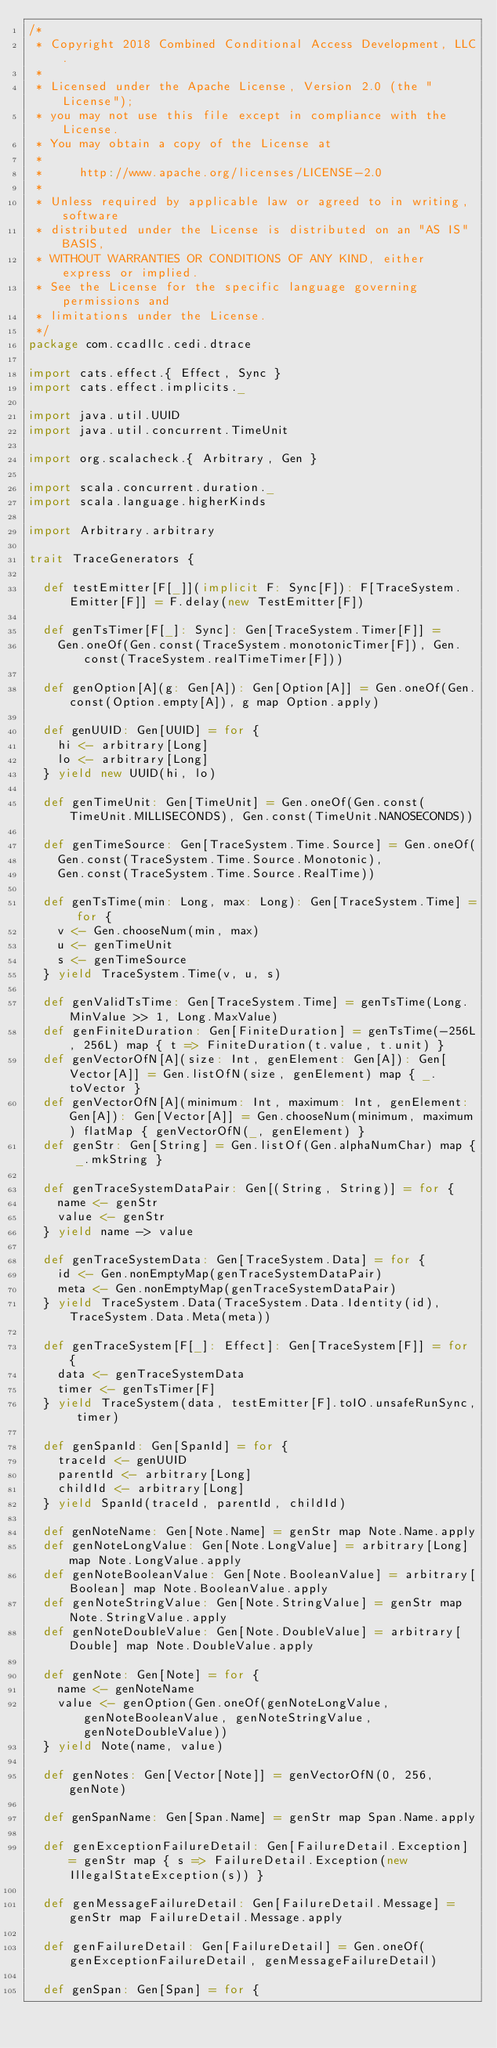<code> <loc_0><loc_0><loc_500><loc_500><_Scala_>/*
 * Copyright 2018 Combined Conditional Access Development, LLC.
 *
 * Licensed under the Apache License, Version 2.0 (the "License");
 * you may not use this file except in compliance with the License.
 * You may obtain a copy of the License at
 *
 *     http://www.apache.org/licenses/LICENSE-2.0
 *
 * Unless required by applicable law or agreed to in writing, software
 * distributed under the License is distributed on an "AS IS" BASIS,
 * WITHOUT WARRANTIES OR CONDITIONS OF ANY KIND, either express or implied.
 * See the License for the specific language governing permissions and
 * limitations under the License.
 */
package com.ccadllc.cedi.dtrace

import cats.effect.{ Effect, Sync }
import cats.effect.implicits._

import java.util.UUID
import java.util.concurrent.TimeUnit

import org.scalacheck.{ Arbitrary, Gen }

import scala.concurrent.duration._
import scala.language.higherKinds

import Arbitrary.arbitrary

trait TraceGenerators {

  def testEmitter[F[_]](implicit F: Sync[F]): F[TraceSystem.Emitter[F]] = F.delay(new TestEmitter[F])

  def genTsTimer[F[_]: Sync]: Gen[TraceSystem.Timer[F]] =
    Gen.oneOf(Gen.const(TraceSystem.monotonicTimer[F]), Gen.const(TraceSystem.realTimeTimer[F]))

  def genOption[A](g: Gen[A]): Gen[Option[A]] = Gen.oneOf(Gen.const(Option.empty[A]), g map Option.apply)

  def genUUID: Gen[UUID] = for {
    hi <- arbitrary[Long]
    lo <- arbitrary[Long]
  } yield new UUID(hi, lo)

  def genTimeUnit: Gen[TimeUnit] = Gen.oneOf(Gen.const(TimeUnit.MILLISECONDS), Gen.const(TimeUnit.NANOSECONDS))

  def genTimeSource: Gen[TraceSystem.Time.Source] = Gen.oneOf(
    Gen.const(TraceSystem.Time.Source.Monotonic),
    Gen.const(TraceSystem.Time.Source.RealTime))

  def genTsTime(min: Long, max: Long): Gen[TraceSystem.Time] = for {
    v <- Gen.chooseNum(min, max)
    u <- genTimeUnit
    s <- genTimeSource
  } yield TraceSystem.Time(v, u, s)

  def genValidTsTime: Gen[TraceSystem.Time] = genTsTime(Long.MinValue >> 1, Long.MaxValue)
  def genFiniteDuration: Gen[FiniteDuration] = genTsTime(-256L, 256L) map { t => FiniteDuration(t.value, t.unit) }
  def genVectorOfN[A](size: Int, genElement: Gen[A]): Gen[Vector[A]] = Gen.listOfN(size, genElement) map { _.toVector }
  def genVectorOfN[A](minimum: Int, maximum: Int, genElement: Gen[A]): Gen[Vector[A]] = Gen.chooseNum(minimum, maximum) flatMap { genVectorOfN(_, genElement) }
  def genStr: Gen[String] = Gen.listOf(Gen.alphaNumChar) map { _.mkString }

  def genTraceSystemDataPair: Gen[(String, String)] = for {
    name <- genStr
    value <- genStr
  } yield name -> value

  def genTraceSystemData: Gen[TraceSystem.Data] = for {
    id <- Gen.nonEmptyMap(genTraceSystemDataPair)
    meta <- Gen.nonEmptyMap(genTraceSystemDataPair)
  } yield TraceSystem.Data(TraceSystem.Data.Identity(id), TraceSystem.Data.Meta(meta))

  def genTraceSystem[F[_]: Effect]: Gen[TraceSystem[F]] = for {
    data <- genTraceSystemData
    timer <- genTsTimer[F]
  } yield TraceSystem(data, testEmitter[F].toIO.unsafeRunSync, timer)

  def genSpanId: Gen[SpanId] = for {
    traceId <- genUUID
    parentId <- arbitrary[Long]
    childId <- arbitrary[Long]
  } yield SpanId(traceId, parentId, childId)

  def genNoteName: Gen[Note.Name] = genStr map Note.Name.apply
  def genNoteLongValue: Gen[Note.LongValue] = arbitrary[Long] map Note.LongValue.apply
  def genNoteBooleanValue: Gen[Note.BooleanValue] = arbitrary[Boolean] map Note.BooleanValue.apply
  def genNoteStringValue: Gen[Note.StringValue] = genStr map Note.StringValue.apply
  def genNoteDoubleValue: Gen[Note.DoubleValue] = arbitrary[Double] map Note.DoubleValue.apply

  def genNote: Gen[Note] = for {
    name <- genNoteName
    value <- genOption(Gen.oneOf(genNoteLongValue, genNoteBooleanValue, genNoteStringValue, genNoteDoubleValue))
  } yield Note(name, value)

  def genNotes: Gen[Vector[Note]] = genVectorOfN(0, 256, genNote)

  def genSpanName: Gen[Span.Name] = genStr map Span.Name.apply

  def genExceptionFailureDetail: Gen[FailureDetail.Exception] = genStr map { s => FailureDetail.Exception(new IllegalStateException(s)) }

  def genMessageFailureDetail: Gen[FailureDetail.Message] = genStr map FailureDetail.Message.apply

  def genFailureDetail: Gen[FailureDetail] = Gen.oneOf(genExceptionFailureDetail, genMessageFailureDetail)

  def genSpan: Gen[Span] = for {</code> 